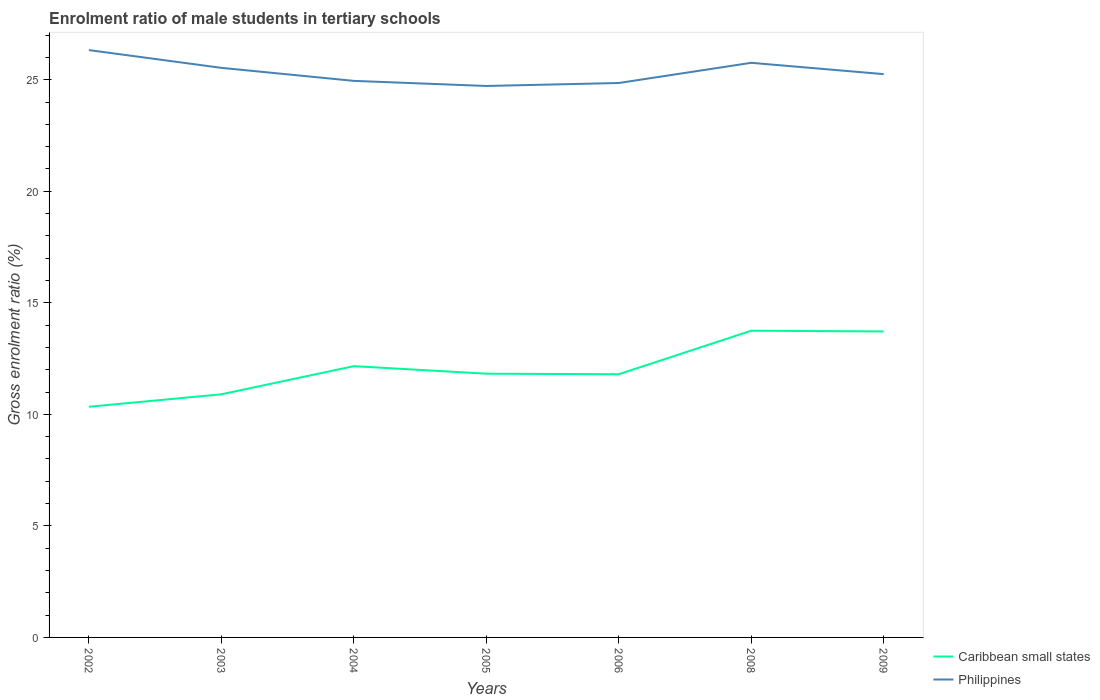How many different coloured lines are there?
Give a very brief answer. 2. Is the number of lines equal to the number of legend labels?
Make the answer very short. Yes. Across all years, what is the maximum enrolment ratio of male students in tertiary schools in Caribbean small states?
Provide a succinct answer. 10.34. In which year was the enrolment ratio of male students in tertiary schools in Caribbean small states maximum?
Give a very brief answer. 2002. What is the total enrolment ratio of male students in tertiary schools in Philippines in the graph?
Your answer should be compact. 0.57. What is the difference between the highest and the second highest enrolment ratio of male students in tertiary schools in Caribbean small states?
Ensure brevity in your answer.  3.41. Is the enrolment ratio of male students in tertiary schools in Caribbean small states strictly greater than the enrolment ratio of male students in tertiary schools in Philippines over the years?
Give a very brief answer. Yes. How many lines are there?
Your response must be concise. 2. Are the values on the major ticks of Y-axis written in scientific E-notation?
Make the answer very short. No. Does the graph contain any zero values?
Your answer should be very brief. No. Does the graph contain grids?
Your answer should be compact. No. How are the legend labels stacked?
Ensure brevity in your answer.  Vertical. What is the title of the graph?
Your answer should be very brief. Enrolment ratio of male students in tertiary schools. What is the label or title of the Y-axis?
Keep it short and to the point. Gross enrolment ratio (%). What is the Gross enrolment ratio (%) in Caribbean small states in 2002?
Your response must be concise. 10.34. What is the Gross enrolment ratio (%) of Philippines in 2002?
Give a very brief answer. 26.33. What is the Gross enrolment ratio (%) in Caribbean small states in 2003?
Ensure brevity in your answer.  10.9. What is the Gross enrolment ratio (%) in Philippines in 2003?
Your answer should be very brief. 25.53. What is the Gross enrolment ratio (%) of Caribbean small states in 2004?
Your answer should be compact. 12.16. What is the Gross enrolment ratio (%) of Philippines in 2004?
Make the answer very short. 24.95. What is the Gross enrolment ratio (%) in Caribbean small states in 2005?
Your response must be concise. 11.82. What is the Gross enrolment ratio (%) of Philippines in 2005?
Make the answer very short. 24.72. What is the Gross enrolment ratio (%) in Caribbean small states in 2006?
Keep it short and to the point. 11.8. What is the Gross enrolment ratio (%) of Philippines in 2006?
Ensure brevity in your answer.  24.85. What is the Gross enrolment ratio (%) in Caribbean small states in 2008?
Keep it short and to the point. 13.75. What is the Gross enrolment ratio (%) in Philippines in 2008?
Offer a very short reply. 25.76. What is the Gross enrolment ratio (%) of Caribbean small states in 2009?
Offer a terse response. 13.72. What is the Gross enrolment ratio (%) of Philippines in 2009?
Give a very brief answer. 25.25. Across all years, what is the maximum Gross enrolment ratio (%) of Caribbean small states?
Keep it short and to the point. 13.75. Across all years, what is the maximum Gross enrolment ratio (%) in Philippines?
Your answer should be very brief. 26.33. Across all years, what is the minimum Gross enrolment ratio (%) of Caribbean small states?
Your response must be concise. 10.34. Across all years, what is the minimum Gross enrolment ratio (%) of Philippines?
Provide a succinct answer. 24.72. What is the total Gross enrolment ratio (%) of Caribbean small states in the graph?
Your answer should be very brief. 84.48. What is the total Gross enrolment ratio (%) in Philippines in the graph?
Make the answer very short. 177.39. What is the difference between the Gross enrolment ratio (%) in Caribbean small states in 2002 and that in 2003?
Your response must be concise. -0.56. What is the difference between the Gross enrolment ratio (%) in Philippines in 2002 and that in 2003?
Your response must be concise. 0.8. What is the difference between the Gross enrolment ratio (%) of Caribbean small states in 2002 and that in 2004?
Your answer should be compact. -1.82. What is the difference between the Gross enrolment ratio (%) in Philippines in 2002 and that in 2004?
Your answer should be very brief. 1.38. What is the difference between the Gross enrolment ratio (%) in Caribbean small states in 2002 and that in 2005?
Keep it short and to the point. -1.48. What is the difference between the Gross enrolment ratio (%) in Philippines in 2002 and that in 2005?
Your answer should be compact. 1.61. What is the difference between the Gross enrolment ratio (%) of Caribbean small states in 2002 and that in 2006?
Make the answer very short. -1.46. What is the difference between the Gross enrolment ratio (%) in Philippines in 2002 and that in 2006?
Provide a short and direct response. 1.48. What is the difference between the Gross enrolment ratio (%) of Caribbean small states in 2002 and that in 2008?
Make the answer very short. -3.41. What is the difference between the Gross enrolment ratio (%) in Philippines in 2002 and that in 2008?
Ensure brevity in your answer.  0.57. What is the difference between the Gross enrolment ratio (%) of Caribbean small states in 2002 and that in 2009?
Your answer should be very brief. -3.38. What is the difference between the Gross enrolment ratio (%) in Philippines in 2002 and that in 2009?
Your answer should be compact. 1.08. What is the difference between the Gross enrolment ratio (%) in Caribbean small states in 2003 and that in 2004?
Your answer should be very brief. -1.26. What is the difference between the Gross enrolment ratio (%) in Philippines in 2003 and that in 2004?
Give a very brief answer. 0.58. What is the difference between the Gross enrolment ratio (%) of Caribbean small states in 2003 and that in 2005?
Your response must be concise. -0.92. What is the difference between the Gross enrolment ratio (%) of Philippines in 2003 and that in 2005?
Your response must be concise. 0.81. What is the difference between the Gross enrolment ratio (%) in Caribbean small states in 2003 and that in 2006?
Offer a very short reply. -0.9. What is the difference between the Gross enrolment ratio (%) of Philippines in 2003 and that in 2006?
Give a very brief answer. 0.68. What is the difference between the Gross enrolment ratio (%) in Caribbean small states in 2003 and that in 2008?
Offer a very short reply. -2.85. What is the difference between the Gross enrolment ratio (%) in Philippines in 2003 and that in 2008?
Your answer should be compact. -0.23. What is the difference between the Gross enrolment ratio (%) of Caribbean small states in 2003 and that in 2009?
Keep it short and to the point. -2.82. What is the difference between the Gross enrolment ratio (%) in Philippines in 2003 and that in 2009?
Make the answer very short. 0.28. What is the difference between the Gross enrolment ratio (%) in Caribbean small states in 2004 and that in 2005?
Offer a very short reply. 0.34. What is the difference between the Gross enrolment ratio (%) of Philippines in 2004 and that in 2005?
Your answer should be very brief. 0.23. What is the difference between the Gross enrolment ratio (%) of Caribbean small states in 2004 and that in 2006?
Offer a very short reply. 0.36. What is the difference between the Gross enrolment ratio (%) of Philippines in 2004 and that in 2006?
Offer a very short reply. 0.1. What is the difference between the Gross enrolment ratio (%) in Caribbean small states in 2004 and that in 2008?
Offer a very short reply. -1.59. What is the difference between the Gross enrolment ratio (%) of Philippines in 2004 and that in 2008?
Make the answer very short. -0.81. What is the difference between the Gross enrolment ratio (%) of Caribbean small states in 2004 and that in 2009?
Your response must be concise. -1.56. What is the difference between the Gross enrolment ratio (%) of Philippines in 2004 and that in 2009?
Offer a terse response. -0.3. What is the difference between the Gross enrolment ratio (%) of Caribbean small states in 2005 and that in 2006?
Give a very brief answer. 0.03. What is the difference between the Gross enrolment ratio (%) in Philippines in 2005 and that in 2006?
Provide a short and direct response. -0.13. What is the difference between the Gross enrolment ratio (%) in Caribbean small states in 2005 and that in 2008?
Provide a short and direct response. -1.93. What is the difference between the Gross enrolment ratio (%) of Philippines in 2005 and that in 2008?
Provide a succinct answer. -1.04. What is the difference between the Gross enrolment ratio (%) of Caribbean small states in 2005 and that in 2009?
Offer a very short reply. -1.89. What is the difference between the Gross enrolment ratio (%) in Philippines in 2005 and that in 2009?
Offer a terse response. -0.53. What is the difference between the Gross enrolment ratio (%) of Caribbean small states in 2006 and that in 2008?
Your response must be concise. -1.95. What is the difference between the Gross enrolment ratio (%) in Philippines in 2006 and that in 2008?
Provide a succinct answer. -0.91. What is the difference between the Gross enrolment ratio (%) of Caribbean small states in 2006 and that in 2009?
Keep it short and to the point. -1.92. What is the difference between the Gross enrolment ratio (%) in Philippines in 2006 and that in 2009?
Keep it short and to the point. -0.4. What is the difference between the Gross enrolment ratio (%) in Caribbean small states in 2008 and that in 2009?
Offer a terse response. 0.03. What is the difference between the Gross enrolment ratio (%) of Philippines in 2008 and that in 2009?
Ensure brevity in your answer.  0.51. What is the difference between the Gross enrolment ratio (%) in Caribbean small states in 2002 and the Gross enrolment ratio (%) in Philippines in 2003?
Make the answer very short. -15.19. What is the difference between the Gross enrolment ratio (%) in Caribbean small states in 2002 and the Gross enrolment ratio (%) in Philippines in 2004?
Offer a very short reply. -14.61. What is the difference between the Gross enrolment ratio (%) of Caribbean small states in 2002 and the Gross enrolment ratio (%) of Philippines in 2005?
Offer a very short reply. -14.38. What is the difference between the Gross enrolment ratio (%) in Caribbean small states in 2002 and the Gross enrolment ratio (%) in Philippines in 2006?
Make the answer very short. -14.51. What is the difference between the Gross enrolment ratio (%) in Caribbean small states in 2002 and the Gross enrolment ratio (%) in Philippines in 2008?
Your response must be concise. -15.42. What is the difference between the Gross enrolment ratio (%) of Caribbean small states in 2002 and the Gross enrolment ratio (%) of Philippines in 2009?
Ensure brevity in your answer.  -14.91. What is the difference between the Gross enrolment ratio (%) in Caribbean small states in 2003 and the Gross enrolment ratio (%) in Philippines in 2004?
Keep it short and to the point. -14.05. What is the difference between the Gross enrolment ratio (%) of Caribbean small states in 2003 and the Gross enrolment ratio (%) of Philippines in 2005?
Offer a terse response. -13.82. What is the difference between the Gross enrolment ratio (%) in Caribbean small states in 2003 and the Gross enrolment ratio (%) in Philippines in 2006?
Ensure brevity in your answer.  -13.95. What is the difference between the Gross enrolment ratio (%) in Caribbean small states in 2003 and the Gross enrolment ratio (%) in Philippines in 2008?
Offer a terse response. -14.86. What is the difference between the Gross enrolment ratio (%) in Caribbean small states in 2003 and the Gross enrolment ratio (%) in Philippines in 2009?
Give a very brief answer. -14.35. What is the difference between the Gross enrolment ratio (%) of Caribbean small states in 2004 and the Gross enrolment ratio (%) of Philippines in 2005?
Keep it short and to the point. -12.56. What is the difference between the Gross enrolment ratio (%) in Caribbean small states in 2004 and the Gross enrolment ratio (%) in Philippines in 2006?
Make the answer very short. -12.69. What is the difference between the Gross enrolment ratio (%) in Caribbean small states in 2004 and the Gross enrolment ratio (%) in Philippines in 2008?
Offer a very short reply. -13.6. What is the difference between the Gross enrolment ratio (%) of Caribbean small states in 2004 and the Gross enrolment ratio (%) of Philippines in 2009?
Provide a succinct answer. -13.09. What is the difference between the Gross enrolment ratio (%) in Caribbean small states in 2005 and the Gross enrolment ratio (%) in Philippines in 2006?
Keep it short and to the point. -13.03. What is the difference between the Gross enrolment ratio (%) in Caribbean small states in 2005 and the Gross enrolment ratio (%) in Philippines in 2008?
Provide a short and direct response. -13.94. What is the difference between the Gross enrolment ratio (%) in Caribbean small states in 2005 and the Gross enrolment ratio (%) in Philippines in 2009?
Provide a succinct answer. -13.43. What is the difference between the Gross enrolment ratio (%) in Caribbean small states in 2006 and the Gross enrolment ratio (%) in Philippines in 2008?
Offer a very short reply. -13.96. What is the difference between the Gross enrolment ratio (%) of Caribbean small states in 2006 and the Gross enrolment ratio (%) of Philippines in 2009?
Your answer should be very brief. -13.45. What is the difference between the Gross enrolment ratio (%) of Caribbean small states in 2008 and the Gross enrolment ratio (%) of Philippines in 2009?
Your answer should be very brief. -11.5. What is the average Gross enrolment ratio (%) of Caribbean small states per year?
Make the answer very short. 12.07. What is the average Gross enrolment ratio (%) of Philippines per year?
Your answer should be compact. 25.34. In the year 2002, what is the difference between the Gross enrolment ratio (%) of Caribbean small states and Gross enrolment ratio (%) of Philippines?
Ensure brevity in your answer.  -15.99. In the year 2003, what is the difference between the Gross enrolment ratio (%) of Caribbean small states and Gross enrolment ratio (%) of Philippines?
Your answer should be very brief. -14.63. In the year 2004, what is the difference between the Gross enrolment ratio (%) in Caribbean small states and Gross enrolment ratio (%) in Philippines?
Your answer should be compact. -12.79. In the year 2005, what is the difference between the Gross enrolment ratio (%) of Caribbean small states and Gross enrolment ratio (%) of Philippines?
Your response must be concise. -12.9. In the year 2006, what is the difference between the Gross enrolment ratio (%) of Caribbean small states and Gross enrolment ratio (%) of Philippines?
Offer a terse response. -13.06. In the year 2008, what is the difference between the Gross enrolment ratio (%) in Caribbean small states and Gross enrolment ratio (%) in Philippines?
Make the answer very short. -12.01. In the year 2009, what is the difference between the Gross enrolment ratio (%) of Caribbean small states and Gross enrolment ratio (%) of Philippines?
Keep it short and to the point. -11.54. What is the ratio of the Gross enrolment ratio (%) of Caribbean small states in 2002 to that in 2003?
Give a very brief answer. 0.95. What is the ratio of the Gross enrolment ratio (%) of Philippines in 2002 to that in 2003?
Offer a terse response. 1.03. What is the ratio of the Gross enrolment ratio (%) in Caribbean small states in 2002 to that in 2004?
Your answer should be very brief. 0.85. What is the ratio of the Gross enrolment ratio (%) of Philippines in 2002 to that in 2004?
Keep it short and to the point. 1.06. What is the ratio of the Gross enrolment ratio (%) in Caribbean small states in 2002 to that in 2005?
Your answer should be very brief. 0.87. What is the ratio of the Gross enrolment ratio (%) of Philippines in 2002 to that in 2005?
Make the answer very short. 1.07. What is the ratio of the Gross enrolment ratio (%) of Caribbean small states in 2002 to that in 2006?
Ensure brevity in your answer.  0.88. What is the ratio of the Gross enrolment ratio (%) in Philippines in 2002 to that in 2006?
Your answer should be very brief. 1.06. What is the ratio of the Gross enrolment ratio (%) in Caribbean small states in 2002 to that in 2008?
Your answer should be very brief. 0.75. What is the ratio of the Gross enrolment ratio (%) of Philippines in 2002 to that in 2008?
Your answer should be very brief. 1.02. What is the ratio of the Gross enrolment ratio (%) of Caribbean small states in 2002 to that in 2009?
Your response must be concise. 0.75. What is the ratio of the Gross enrolment ratio (%) of Philippines in 2002 to that in 2009?
Offer a terse response. 1.04. What is the ratio of the Gross enrolment ratio (%) in Caribbean small states in 2003 to that in 2004?
Your answer should be compact. 0.9. What is the ratio of the Gross enrolment ratio (%) in Philippines in 2003 to that in 2004?
Offer a terse response. 1.02. What is the ratio of the Gross enrolment ratio (%) of Caribbean small states in 2003 to that in 2005?
Provide a short and direct response. 0.92. What is the ratio of the Gross enrolment ratio (%) in Philippines in 2003 to that in 2005?
Make the answer very short. 1.03. What is the ratio of the Gross enrolment ratio (%) in Caribbean small states in 2003 to that in 2006?
Your answer should be very brief. 0.92. What is the ratio of the Gross enrolment ratio (%) of Philippines in 2003 to that in 2006?
Ensure brevity in your answer.  1.03. What is the ratio of the Gross enrolment ratio (%) of Caribbean small states in 2003 to that in 2008?
Provide a short and direct response. 0.79. What is the ratio of the Gross enrolment ratio (%) of Philippines in 2003 to that in 2008?
Provide a short and direct response. 0.99. What is the ratio of the Gross enrolment ratio (%) of Caribbean small states in 2003 to that in 2009?
Make the answer very short. 0.79. What is the ratio of the Gross enrolment ratio (%) of Philippines in 2003 to that in 2009?
Provide a short and direct response. 1.01. What is the ratio of the Gross enrolment ratio (%) of Caribbean small states in 2004 to that in 2005?
Offer a very short reply. 1.03. What is the ratio of the Gross enrolment ratio (%) of Philippines in 2004 to that in 2005?
Offer a very short reply. 1.01. What is the ratio of the Gross enrolment ratio (%) in Caribbean small states in 2004 to that in 2006?
Give a very brief answer. 1.03. What is the ratio of the Gross enrolment ratio (%) of Caribbean small states in 2004 to that in 2008?
Make the answer very short. 0.88. What is the ratio of the Gross enrolment ratio (%) of Philippines in 2004 to that in 2008?
Give a very brief answer. 0.97. What is the ratio of the Gross enrolment ratio (%) of Caribbean small states in 2004 to that in 2009?
Provide a succinct answer. 0.89. What is the ratio of the Gross enrolment ratio (%) in Caribbean small states in 2005 to that in 2006?
Your answer should be very brief. 1. What is the ratio of the Gross enrolment ratio (%) of Caribbean small states in 2005 to that in 2008?
Your answer should be very brief. 0.86. What is the ratio of the Gross enrolment ratio (%) in Philippines in 2005 to that in 2008?
Keep it short and to the point. 0.96. What is the ratio of the Gross enrolment ratio (%) of Caribbean small states in 2005 to that in 2009?
Provide a short and direct response. 0.86. What is the ratio of the Gross enrolment ratio (%) in Caribbean small states in 2006 to that in 2008?
Your answer should be compact. 0.86. What is the ratio of the Gross enrolment ratio (%) in Philippines in 2006 to that in 2008?
Provide a short and direct response. 0.96. What is the ratio of the Gross enrolment ratio (%) of Caribbean small states in 2006 to that in 2009?
Keep it short and to the point. 0.86. What is the ratio of the Gross enrolment ratio (%) in Philippines in 2006 to that in 2009?
Provide a succinct answer. 0.98. What is the ratio of the Gross enrolment ratio (%) of Caribbean small states in 2008 to that in 2009?
Make the answer very short. 1. What is the ratio of the Gross enrolment ratio (%) of Philippines in 2008 to that in 2009?
Make the answer very short. 1.02. What is the difference between the highest and the second highest Gross enrolment ratio (%) in Caribbean small states?
Your response must be concise. 0.03. What is the difference between the highest and the second highest Gross enrolment ratio (%) of Philippines?
Give a very brief answer. 0.57. What is the difference between the highest and the lowest Gross enrolment ratio (%) in Caribbean small states?
Give a very brief answer. 3.41. What is the difference between the highest and the lowest Gross enrolment ratio (%) of Philippines?
Your answer should be compact. 1.61. 